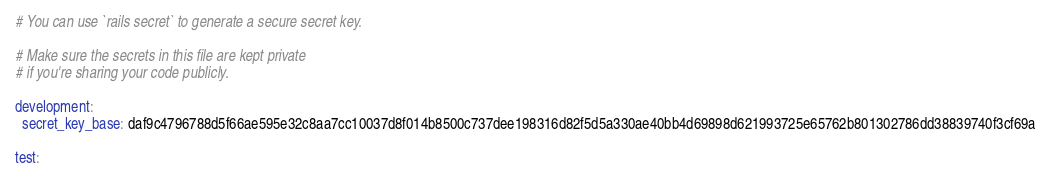<code> <loc_0><loc_0><loc_500><loc_500><_YAML_># You can use `rails secret` to generate a secure secret key.

# Make sure the secrets in this file are kept private
# if you're sharing your code publicly.

development:
  secret_key_base: daf9c4796788d5f66ae595e32c8aa7cc10037d8f014b8500c737dee198316d82f5d5a330ae40bb4d69898d621993725e65762b801302786dd38839740f3cf69a

test:</code> 